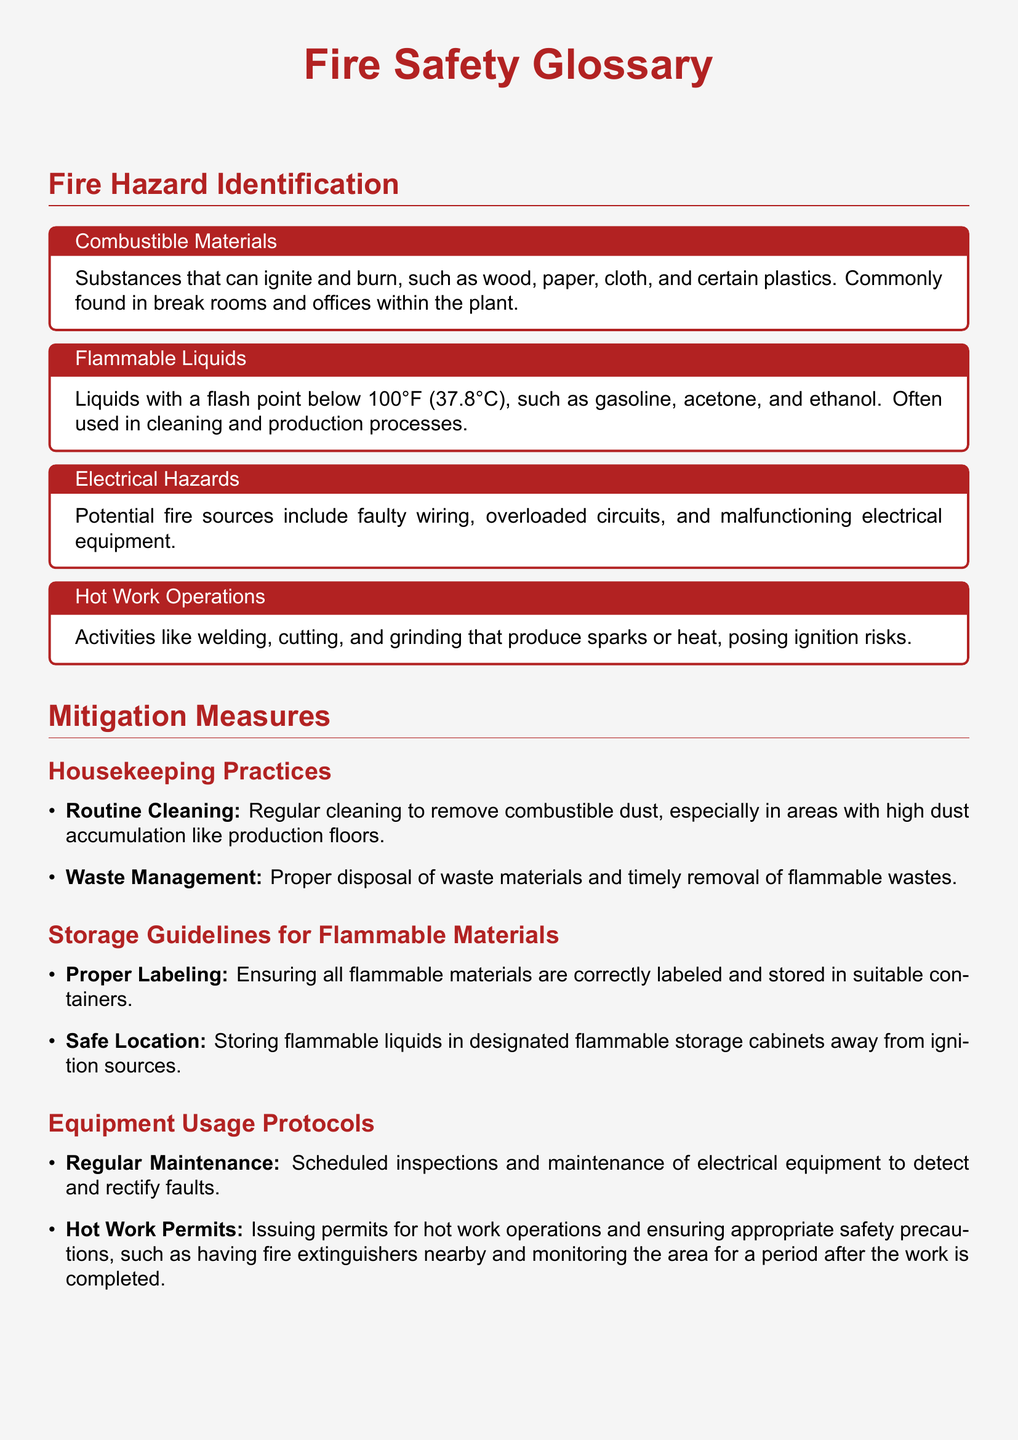What are considered combustible materials? The glossary defines combustible materials as substances that can ignite and burn, such as wood, paper, cloth, and certain plastics.
Answer: Wood, paper, cloth, plastics What is the flash point threshold for flammable liquids? The document states that flammable liquids have a flash point below 100°F (37.8°C).
Answer: 100°F What are common electrical hazards mentioned? The document lists faulty wiring, overloaded circuits, and malfunctioning electrical equipment as potential fire sources.
Answer: Faulty wiring, overloaded circuits, malfunctioning electrical equipment What is one of the housekeeping practices for fire hazard mitigation? The document emphasizes the importance of regular cleaning to remove combustible dust as a housekeeping practice.
Answer: Routine cleaning Where should flammable liquids be stored? The glossary states that flammable liquids should be stored in designated flammable storage cabinets away from ignition sources.
Answer: Flammable storage cabinets What is required for hot work operations? The document specifies that hot work operations require issuing permits and ensuring appropriate safety precautions.
Answer: Hot work permits What is a recommended practice for equipment usage? The glossary advises regular maintenance of electrical equipment to detect and rectify faults.
Answer: Regular maintenance Which activity is considered a hot work operation? The glossary identifies activities like welding, cutting, and grinding as hot work operations.
Answer: Welding, cutting, grinding What type of materials should be properly labeled? The document specifies that flammable materials should be correctly labeled when stored.
Answer: Flammable materials 